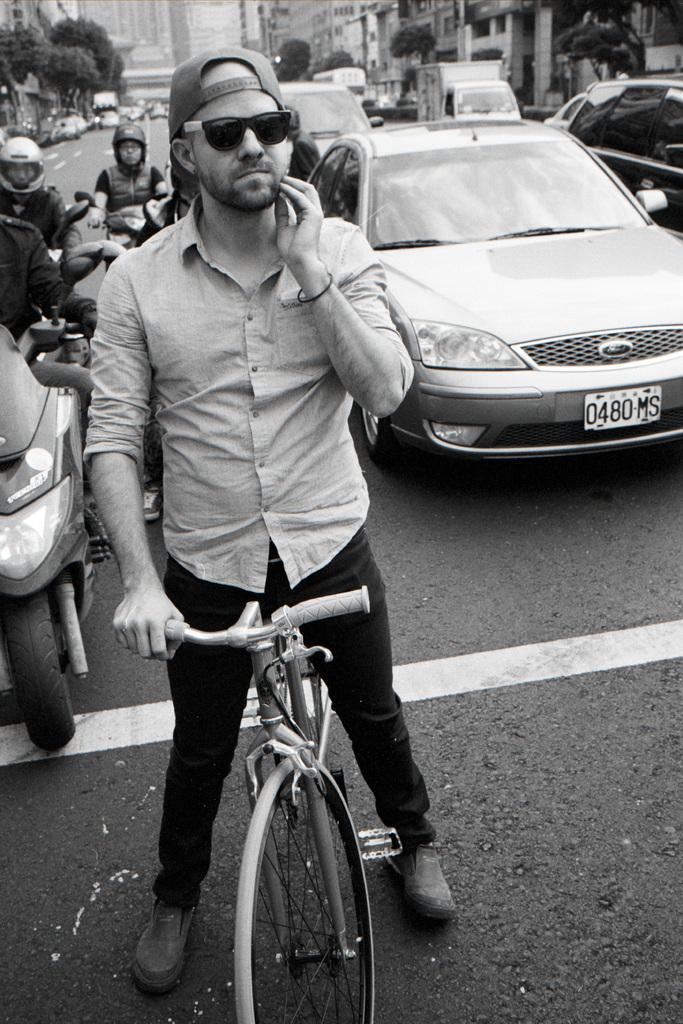How would you summarize this image in a sentence or two? In this image I can see a group of vehicles are standing on the road with people. 